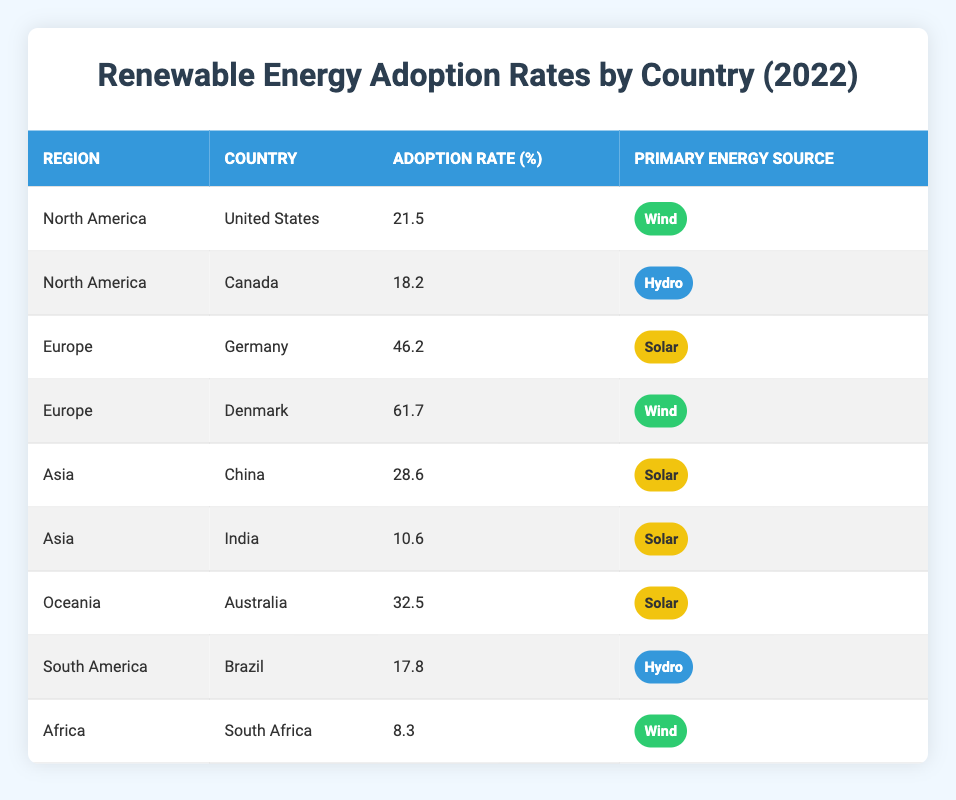What is the adoption rate of renewable energy in Germany? The table shows that Germany has an adoption rate of 46.2% for renewable energy in 2022.
Answer: 46.2% Which country in North America has the highest renewable energy adoption rate? By comparing the adoption rates of the United States (21.5%) and Canada (18.2%), the United States has the higher rate.
Answer: United States Is the adoption rate of renewable energy in South Africa higher than in India? South Africa has an adoption rate of 8.3% while India has a rate of 10.6%. Since 8.3% is less than 10.6%, the statement is false.
Answer: No What is the average renewable energy adoption rate across all listed countries? To find the average, sum all the adoption rates: 21.5 + 18.2 + 46.2 + 61.7 + 28.6 + 10.6 + 32.5 + 17.8 + 8.3 =  345.4. Then divide by the number of countries (9): 345.4 / 9 ≈ 38.4.
Answer: 38.4 In which region does Denmark belong, and what is its primary energy source? The table indicates that Denmark is in Europe and its primary energy source is Wind.
Answer: Europe, Wind 